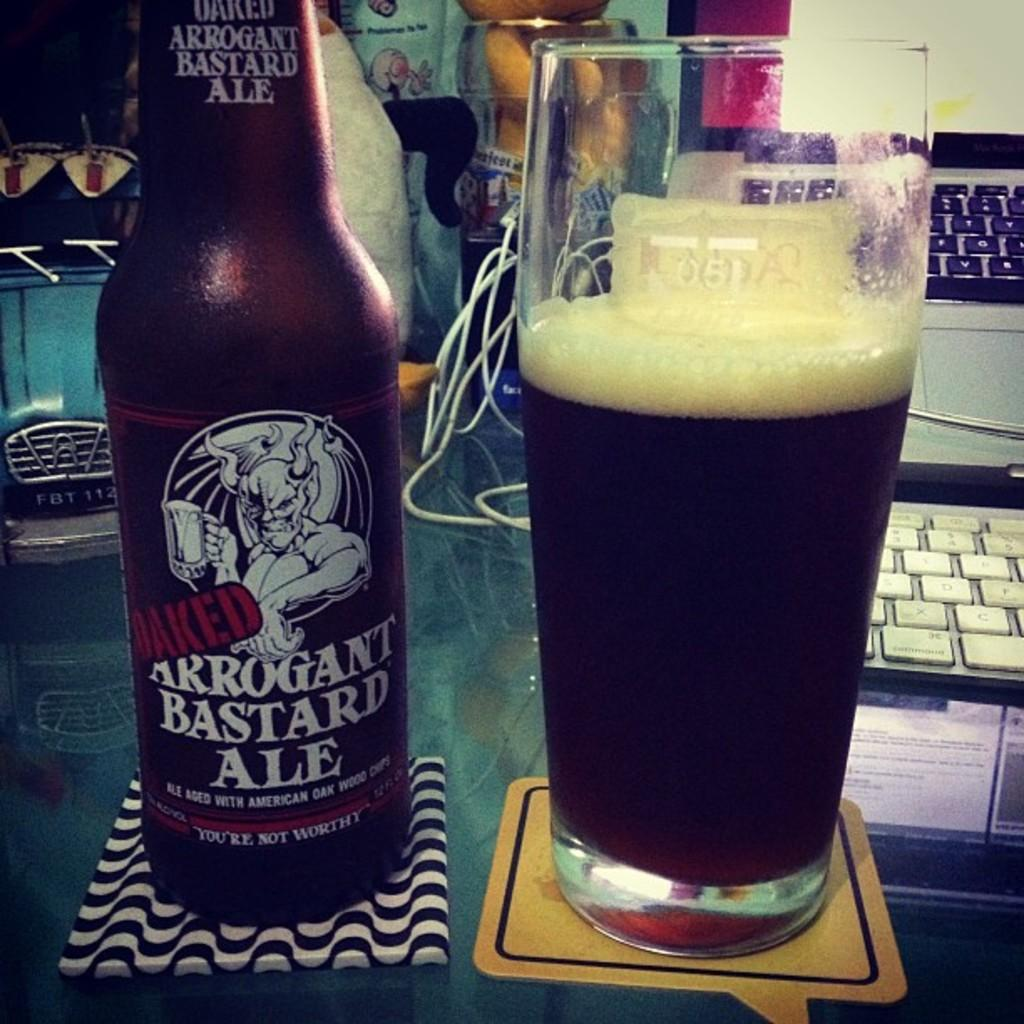<image>
Relay a brief, clear account of the picture shown. A bottle of Arrogant Bastard Ale is next to a full glass of beer. 